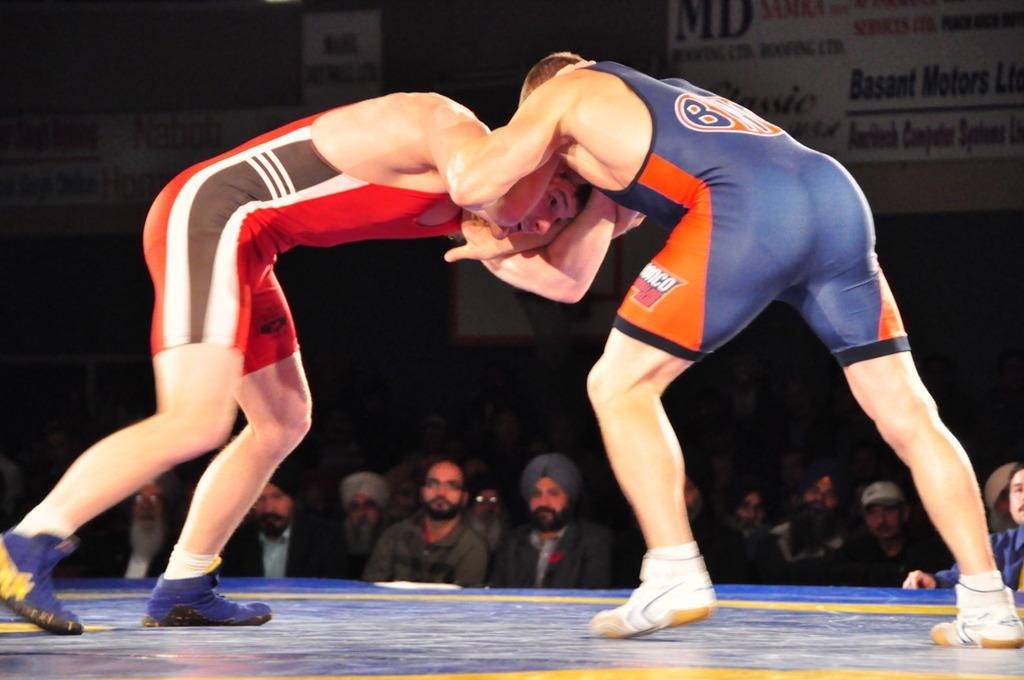<image>
Write a terse but informative summary of the picture. two boxers in a ring sponsored in part by basant motors 